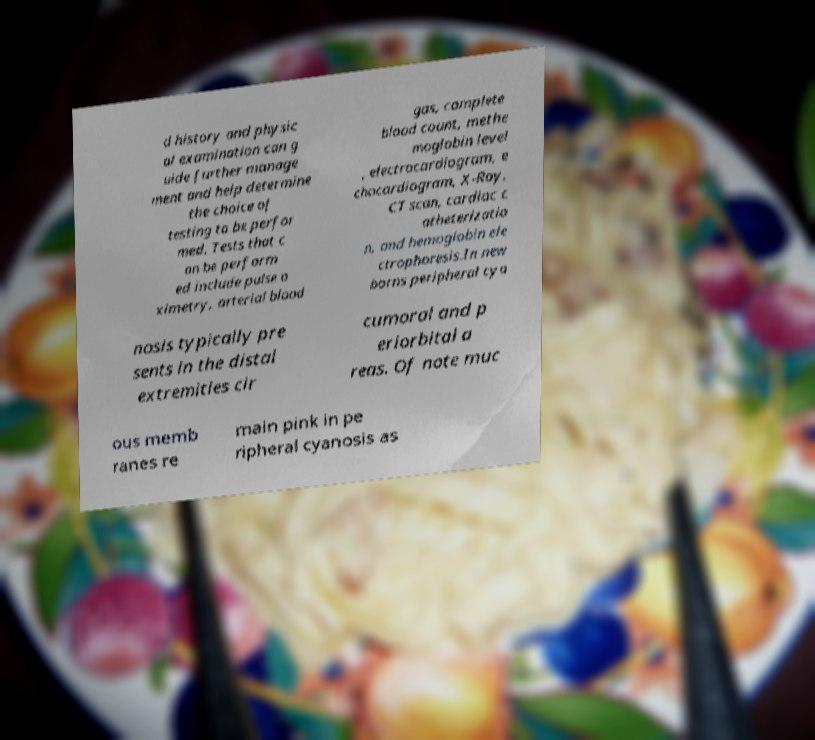There's text embedded in this image that I need extracted. Can you transcribe it verbatim? d history and physic al examination can g uide further manage ment and help determine the choice of testing to be perfor med. Tests that c an be perform ed include pulse o ximetry, arterial blood gas, complete blood count, methe moglobin level , electrocardiogram, e chocardiogram, X-Ray, CT scan, cardiac c atheterizatio n, and hemoglobin ele ctrophoresis.In new borns peripheral cya nosis typically pre sents in the distal extremities cir cumoral and p eriorbital a reas. Of note muc ous memb ranes re main pink in pe ripheral cyanosis as 